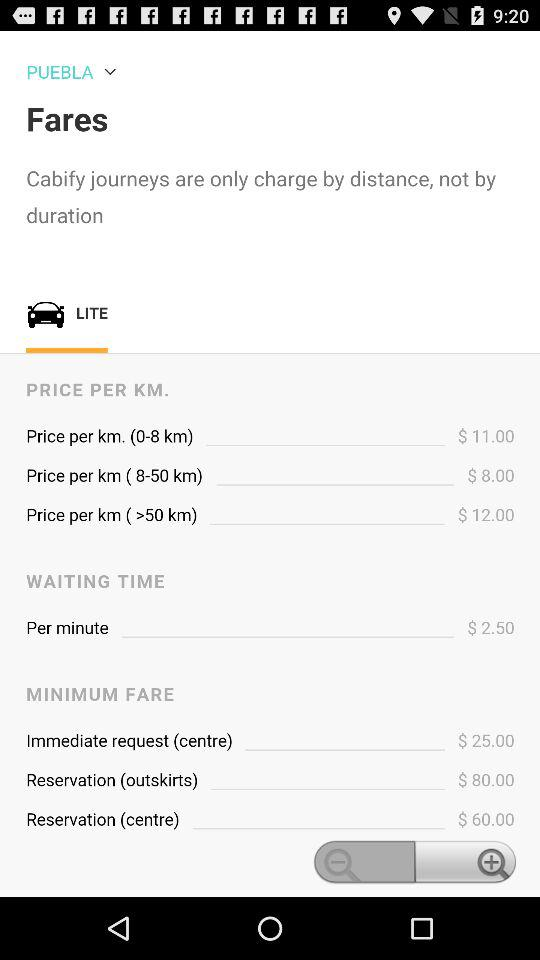How much is the "LITE" fare per kilometer for over 50km in rupees?
When the provided information is insufficient, respond with <no answer>. <no answer> 